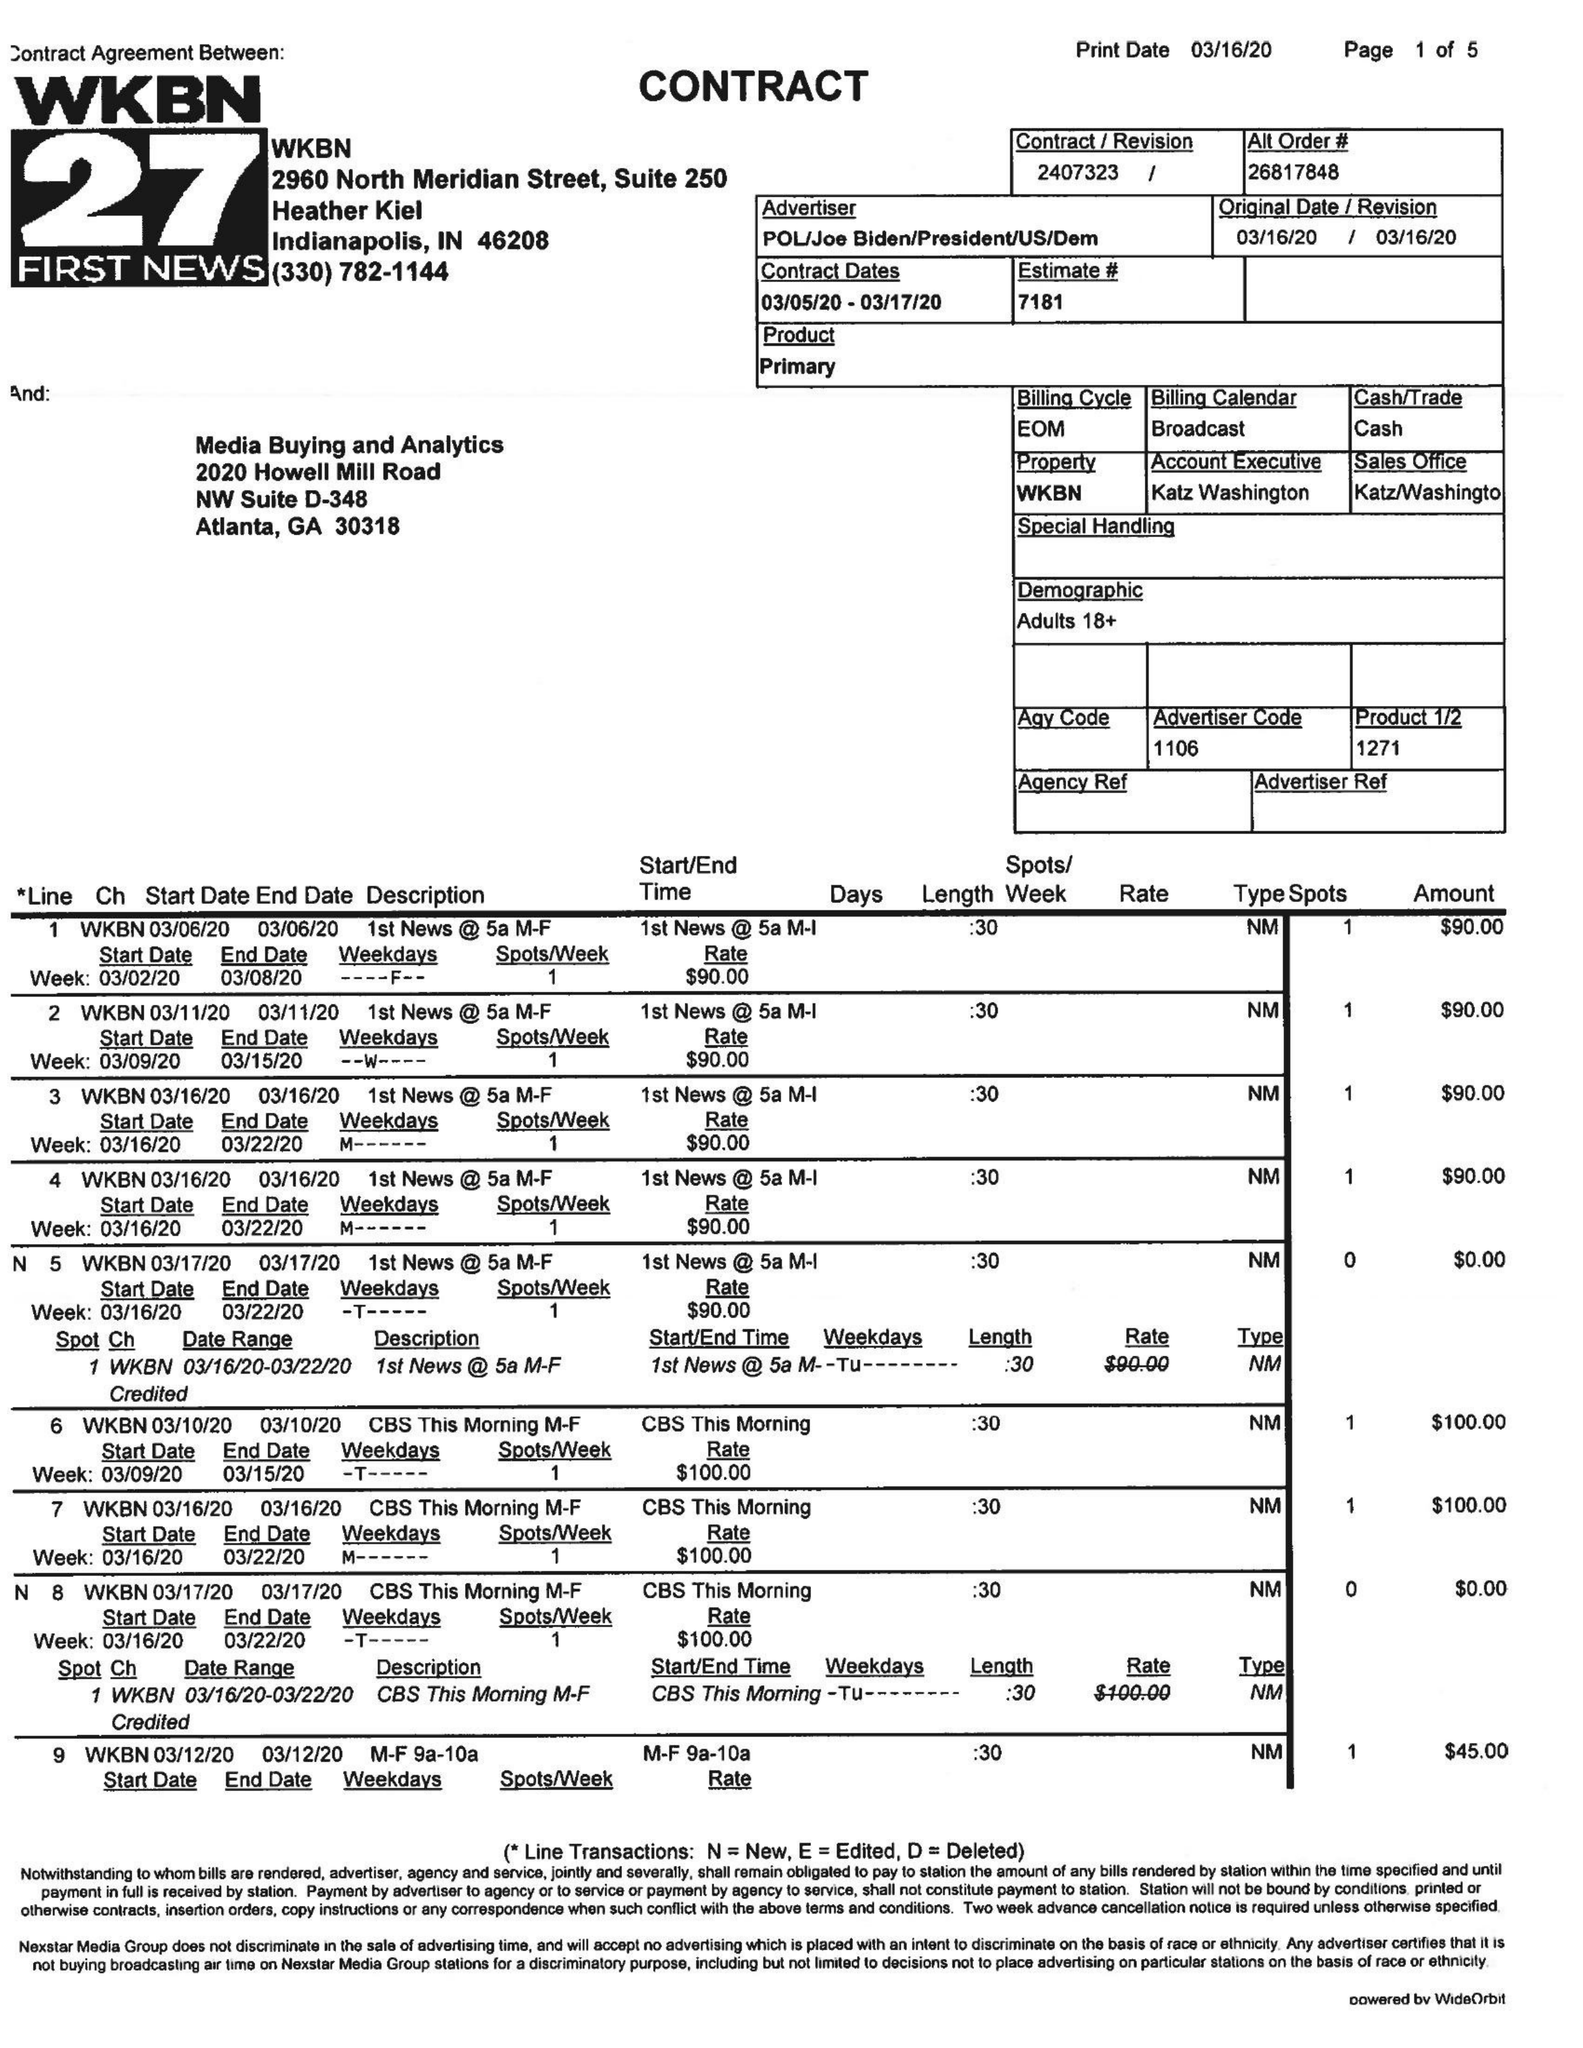What is the value for the flight_to?
Answer the question using a single word or phrase. 03/17/20 